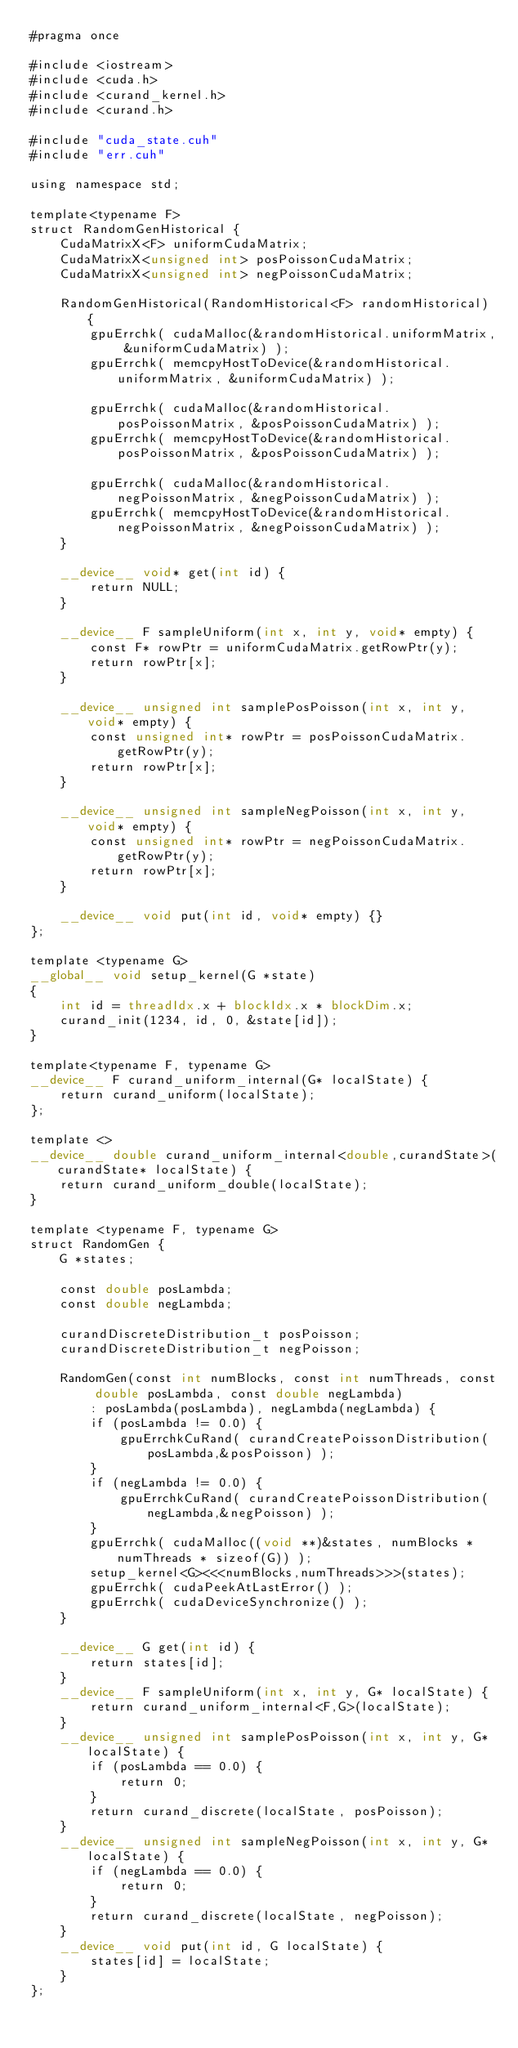Convert code to text. <code><loc_0><loc_0><loc_500><loc_500><_Cuda_>#pragma once

#include <iostream>
#include <cuda.h>
#include <curand_kernel.h>
#include <curand.h>

#include "cuda_state.cuh"
#include "err.cuh"

using namespace std;

template<typename F>
struct RandomGenHistorical {
    CudaMatrixX<F> uniformCudaMatrix;
    CudaMatrixX<unsigned int> posPoissonCudaMatrix;
    CudaMatrixX<unsigned int> negPoissonCudaMatrix;

    RandomGenHistorical(RandomHistorical<F> randomHistorical) {
        gpuErrchk( cudaMalloc(&randomHistorical.uniformMatrix, &uniformCudaMatrix) );
        gpuErrchk( memcpyHostToDevice(&randomHistorical.uniformMatrix, &uniformCudaMatrix) );

        gpuErrchk( cudaMalloc(&randomHistorical.posPoissonMatrix, &posPoissonCudaMatrix) );
        gpuErrchk( memcpyHostToDevice(&randomHistorical.posPoissonMatrix, &posPoissonCudaMatrix) );

        gpuErrchk( cudaMalloc(&randomHistorical.negPoissonMatrix, &negPoissonCudaMatrix) );
        gpuErrchk( memcpyHostToDevice(&randomHistorical.negPoissonMatrix, &negPoissonCudaMatrix) );
    }
    
    __device__ void* get(int id) {
        return NULL;
    }
    
    __device__ F sampleUniform(int x, int y, void* empty) {
        const F* rowPtr = uniformCudaMatrix.getRowPtr(y);
        return rowPtr[x];
    }
    
    __device__ unsigned int samplePosPoisson(int x, int y, void* empty) {
        const unsigned int* rowPtr = posPoissonCudaMatrix.getRowPtr(y);
        return rowPtr[x];
    }
    
    __device__ unsigned int sampleNegPoisson(int x, int y, void* empty) {
        const unsigned int* rowPtr = negPoissonCudaMatrix.getRowPtr(y);
        return rowPtr[x];
    }
    
    __device__ void put(int id, void* empty) {}
};

template <typename G>
__global__ void setup_kernel(G *state)
{
    int id = threadIdx.x + blockIdx.x * blockDim.x;
    curand_init(1234, id, 0, &state[id]);
}

template<typename F, typename G>
__device__ F curand_uniform_internal(G* localState) {
    return curand_uniform(localState);
};

template <>
__device__ double curand_uniform_internal<double,curandState>(curandState* localState) {
    return curand_uniform_double(localState);
}

template <typename F, typename G>
struct RandomGen {
    G *states;

    const double posLambda;
    const double negLambda;

    curandDiscreteDistribution_t posPoisson;
    curandDiscreteDistribution_t negPoisson;

    RandomGen(const int numBlocks, const int numThreads, const double posLambda, const double negLambda)
        : posLambda(posLambda), negLambda(negLambda) {
        if (posLambda != 0.0) {
            gpuErrchkCuRand( curandCreatePoissonDistribution(posLambda,&posPoisson) );
        }
        if (negLambda != 0.0) {
            gpuErrchkCuRand( curandCreatePoissonDistribution(negLambda,&negPoisson) );
        }
        gpuErrchk( cudaMalloc((void **)&states, numBlocks * numThreads * sizeof(G)) );
        setup_kernel<G><<<numBlocks,numThreads>>>(states);
        gpuErrchk( cudaPeekAtLastError() );
        gpuErrchk( cudaDeviceSynchronize() );
    }

    __device__ G get(int id) {
        return states[id];
    }
    __device__ F sampleUniform(int x, int y, G* localState) {
        return curand_uniform_internal<F,G>(localState);
    }
    __device__ unsigned int samplePosPoisson(int x, int y, G* localState) {
        if (posLambda == 0.0) {
            return 0;
        }
        return curand_discrete(localState, posPoisson);
    }
    __device__ unsigned int sampleNegPoisson(int x, int y, G* localState) {
        if (negLambda == 0.0) {
            return 0;
        }
        return curand_discrete(localState, negPoisson);
    }
    __device__ void put(int id, G localState) {
        states[id] = localState;
    }
};

</code> 